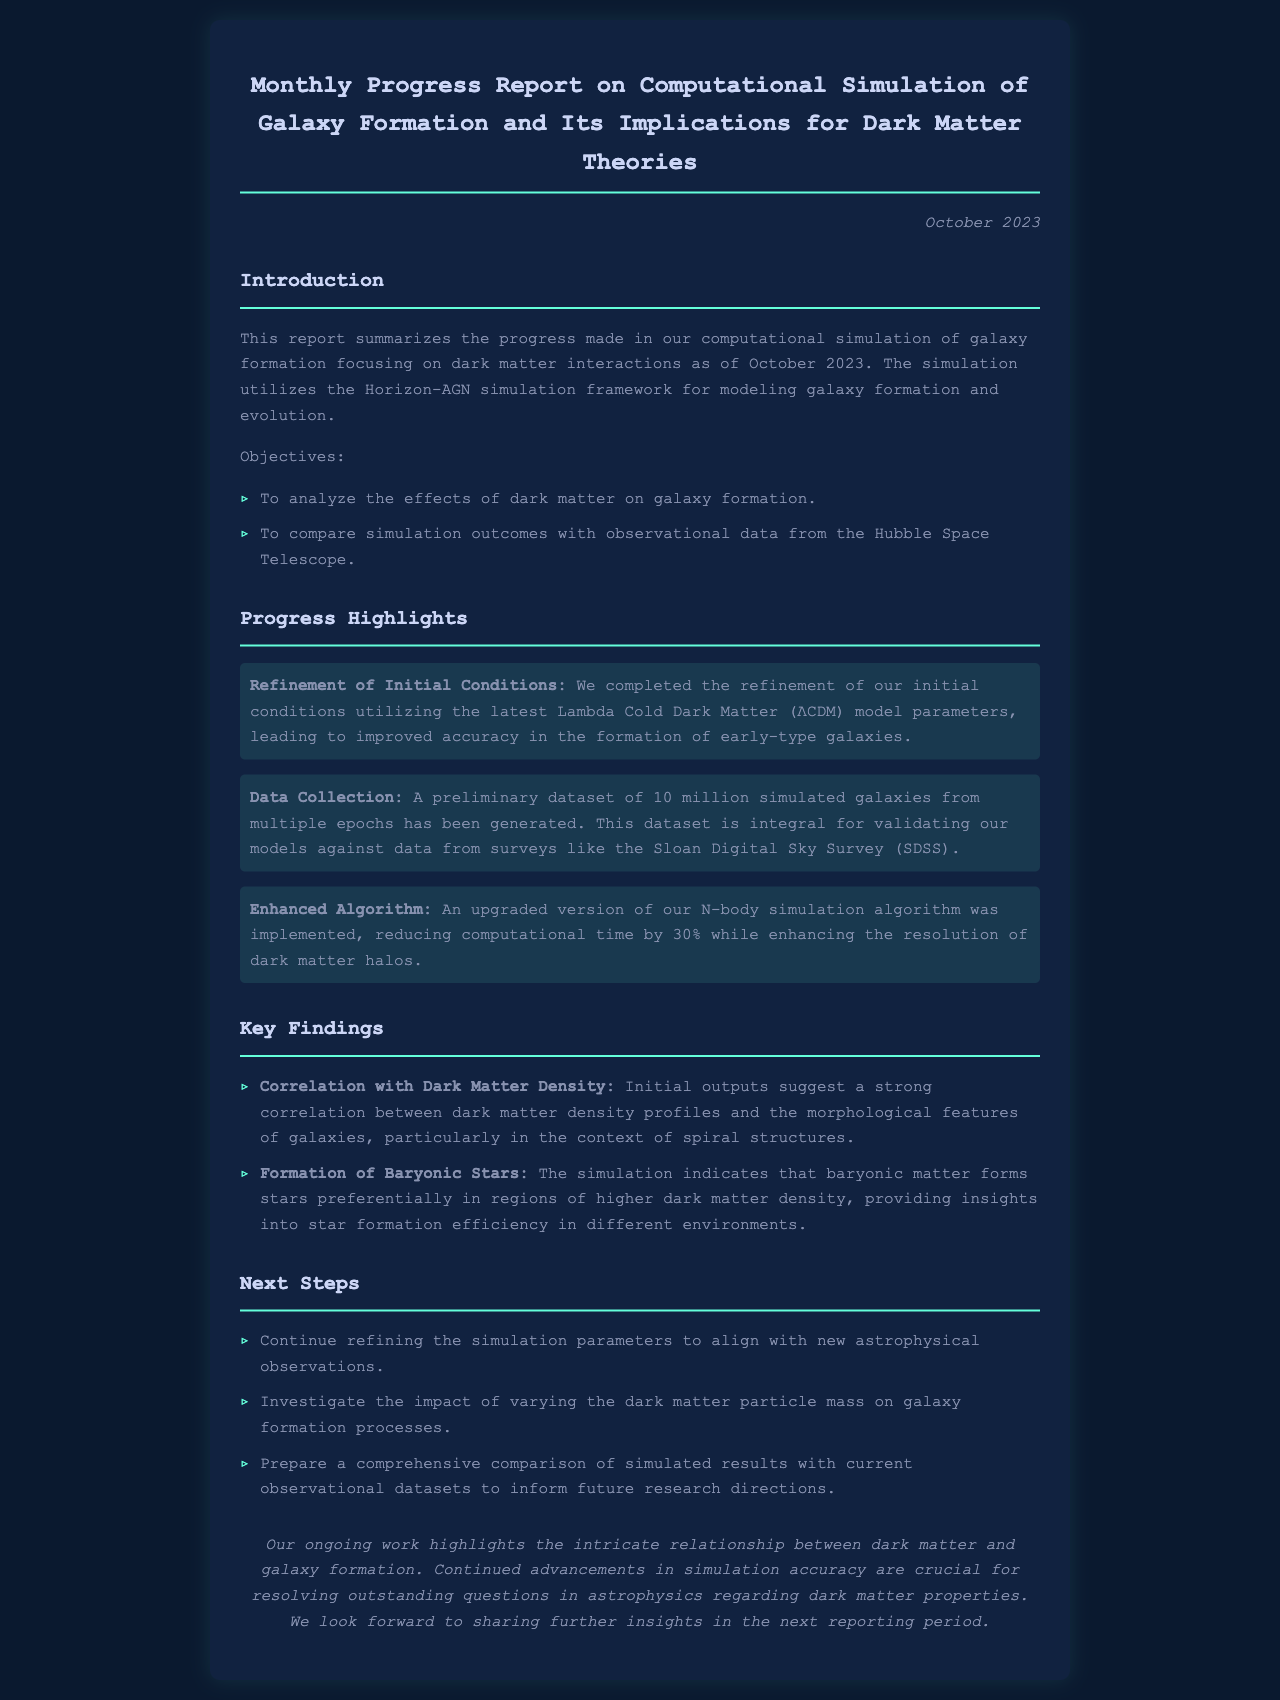What is the month and year of the report? The report states it was published in October 2023.
Answer: October 2023 What simulation framework was used? The document mentions the Horizon-AGN simulation framework.
Answer: Horizon-AGN How many simulated galaxies were generated? The report indicates that a preliminary dataset of 10 million simulated galaxies was produced.
Answer: 10 million What is one objective of the simulation? One objective mentioned is to analyze the effects of dark matter on galaxy formation.
Answer: Analyze the effects of dark matter on galaxy formation What percentage reduction in computational time was achieved? The enhanced algorithm reduced computational time by 30%.
Answer: 30% What is one key finding regarding dark matter? It was found that there is a strong correlation between dark matter density profiles and morphological features of galaxies.
Answer: Strong correlation What is one of the next steps outlined in the report? The next steps include continuing to refine the simulation parameters to align with new astrophysical observations.
Answer: Refine the simulation parameters What type of galaxy structures were particularly studied? The report notes that the study focused on spiral structures of galaxies.
Answer: Spiral structures What effect of dark matter does the report suggest on baryonic star formation? The simulation indicates that baryonic matter forms stars preferentially in regions of higher dark matter density.
Answer: Higher dark matter density 